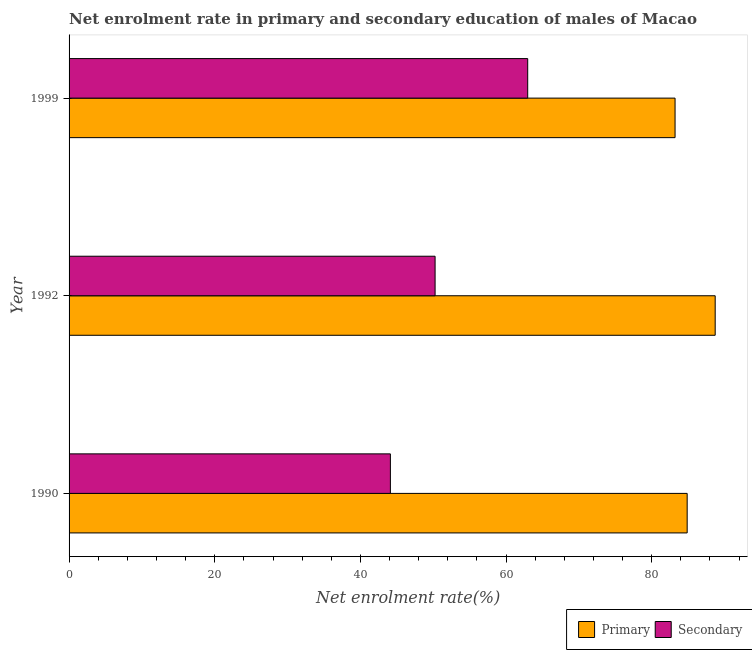How many different coloured bars are there?
Your answer should be compact. 2. How many bars are there on the 2nd tick from the top?
Keep it short and to the point. 2. What is the enrollment rate in primary education in 1990?
Provide a succinct answer. 84.87. Across all years, what is the maximum enrollment rate in primary education?
Keep it short and to the point. 88.71. Across all years, what is the minimum enrollment rate in primary education?
Your answer should be compact. 83.2. What is the total enrollment rate in secondary education in the graph?
Your answer should be very brief. 157.35. What is the difference between the enrollment rate in primary education in 1990 and that in 1999?
Provide a short and direct response. 1.66. What is the difference between the enrollment rate in primary education in 1992 and the enrollment rate in secondary education in 1990?
Provide a succinct answer. 44.6. What is the average enrollment rate in secondary education per year?
Keep it short and to the point. 52.45. In the year 1999, what is the difference between the enrollment rate in secondary education and enrollment rate in primary education?
Your answer should be very brief. -20.23. In how many years, is the enrollment rate in secondary education greater than 4 %?
Offer a terse response. 3. What is the ratio of the enrollment rate in primary education in 1990 to that in 1999?
Provide a short and direct response. 1.02. Is the enrollment rate in primary education in 1992 less than that in 1999?
Keep it short and to the point. No. Is the difference between the enrollment rate in secondary education in 1992 and 1999 greater than the difference between the enrollment rate in primary education in 1992 and 1999?
Offer a terse response. No. What is the difference between the highest and the second highest enrollment rate in secondary education?
Ensure brevity in your answer.  12.72. What is the difference between the highest and the lowest enrollment rate in secondary education?
Give a very brief answer. 18.85. In how many years, is the enrollment rate in primary education greater than the average enrollment rate in primary education taken over all years?
Give a very brief answer. 1. What does the 2nd bar from the top in 1990 represents?
Your answer should be very brief. Primary. What does the 1st bar from the bottom in 1990 represents?
Offer a terse response. Primary. Are all the bars in the graph horizontal?
Offer a very short reply. Yes. How many years are there in the graph?
Offer a very short reply. 3. Does the graph contain any zero values?
Your answer should be very brief. No. Where does the legend appear in the graph?
Your answer should be compact. Bottom right. How many legend labels are there?
Give a very brief answer. 2. What is the title of the graph?
Offer a terse response. Net enrolment rate in primary and secondary education of males of Macao. What is the label or title of the X-axis?
Offer a very short reply. Net enrolment rate(%). What is the label or title of the Y-axis?
Ensure brevity in your answer.  Year. What is the Net enrolment rate(%) in Primary in 1990?
Your answer should be compact. 84.87. What is the Net enrolment rate(%) of Secondary in 1990?
Provide a succinct answer. 44.12. What is the Net enrolment rate(%) in Primary in 1992?
Make the answer very short. 88.71. What is the Net enrolment rate(%) of Secondary in 1992?
Make the answer very short. 50.26. What is the Net enrolment rate(%) in Primary in 1999?
Your response must be concise. 83.2. What is the Net enrolment rate(%) of Secondary in 1999?
Provide a short and direct response. 62.97. Across all years, what is the maximum Net enrolment rate(%) in Primary?
Offer a terse response. 88.71. Across all years, what is the maximum Net enrolment rate(%) in Secondary?
Provide a short and direct response. 62.97. Across all years, what is the minimum Net enrolment rate(%) of Primary?
Keep it short and to the point. 83.2. Across all years, what is the minimum Net enrolment rate(%) of Secondary?
Provide a succinct answer. 44.12. What is the total Net enrolment rate(%) in Primary in the graph?
Give a very brief answer. 256.79. What is the total Net enrolment rate(%) in Secondary in the graph?
Your response must be concise. 157.35. What is the difference between the Net enrolment rate(%) in Primary in 1990 and that in 1992?
Offer a terse response. -3.85. What is the difference between the Net enrolment rate(%) of Secondary in 1990 and that in 1992?
Offer a very short reply. -6.14. What is the difference between the Net enrolment rate(%) of Primary in 1990 and that in 1999?
Make the answer very short. 1.66. What is the difference between the Net enrolment rate(%) in Secondary in 1990 and that in 1999?
Provide a succinct answer. -18.85. What is the difference between the Net enrolment rate(%) of Primary in 1992 and that in 1999?
Make the answer very short. 5.51. What is the difference between the Net enrolment rate(%) of Secondary in 1992 and that in 1999?
Give a very brief answer. -12.72. What is the difference between the Net enrolment rate(%) of Primary in 1990 and the Net enrolment rate(%) of Secondary in 1992?
Make the answer very short. 34.61. What is the difference between the Net enrolment rate(%) of Primary in 1990 and the Net enrolment rate(%) of Secondary in 1999?
Make the answer very short. 21.9. What is the difference between the Net enrolment rate(%) in Primary in 1992 and the Net enrolment rate(%) in Secondary in 1999?
Your response must be concise. 25.74. What is the average Net enrolment rate(%) in Primary per year?
Keep it short and to the point. 85.6. What is the average Net enrolment rate(%) in Secondary per year?
Your answer should be compact. 52.45. In the year 1990, what is the difference between the Net enrolment rate(%) in Primary and Net enrolment rate(%) in Secondary?
Your answer should be very brief. 40.75. In the year 1992, what is the difference between the Net enrolment rate(%) in Primary and Net enrolment rate(%) in Secondary?
Make the answer very short. 38.46. In the year 1999, what is the difference between the Net enrolment rate(%) of Primary and Net enrolment rate(%) of Secondary?
Provide a succinct answer. 20.23. What is the ratio of the Net enrolment rate(%) in Primary in 1990 to that in 1992?
Your response must be concise. 0.96. What is the ratio of the Net enrolment rate(%) of Secondary in 1990 to that in 1992?
Ensure brevity in your answer.  0.88. What is the ratio of the Net enrolment rate(%) of Primary in 1990 to that in 1999?
Offer a very short reply. 1.02. What is the ratio of the Net enrolment rate(%) in Secondary in 1990 to that in 1999?
Provide a short and direct response. 0.7. What is the ratio of the Net enrolment rate(%) of Primary in 1992 to that in 1999?
Your answer should be very brief. 1.07. What is the ratio of the Net enrolment rate(%) of Secondary in 1992 to that in 1999?
Ensure brevity in your answer.  0.8. What is the difference between the highest and the second highest Net enrolment rate(%) of Primary?
Offer a terse response. 3.85. What is the difference between the highest and the second highest Net enrolment rate(%) of Secondary?
Provide a succinct answer. 12.72. What is the difference between the highest and the lowest Net enrolment rate(%) of Primary?
Ensure brevity in your answer.  5.51. What is the difference between the highest and the lowest Net enrolment rate(%) of Secondary?
Give a very brief answer. 18.85. 